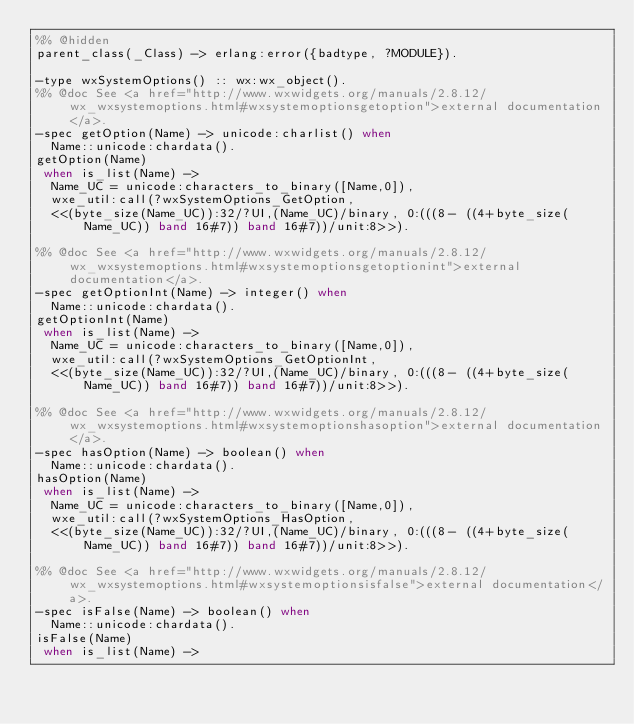<code> <loc_0><loc_0><loc_500><loc_500><_Erlang_>%% @hidden
parent_class(_Class) -> erlang:error({badtype, ?MODULE}).

-type wxSystemOptions() :: wx:wx_object().
%% @doc See <a href="http://www.wxwidgets.org/manuals/2.8.12/wx_wxsystemoptions.html#wxsystemoptionsgetoption">external documentation</a>.
-spec getOption(Name) -> unicode:charlist() when
	Name::unicode:chardata().
getOption(Name)
 when is_list(Name) ->
  Name_UC = unicode:characters_to_binary([Name,0]),
  wxe_util:call(?wxSystemOptions_GetOption,
  <<(byte_size(Name_UC)):32/?UI,(Name_UC)/binary, 0:(((8- ((4+byte_size(Name_UC)) band 16#7)) band 16#7))/unit:8>>).

%% @doc See <a href="http://www.wxwidgets.org/manuals/2.8.12/wx_wxsystemoptions.html#wxsystemoptionsgetoptionint">external documentation</a>.
-spec getOptionInt(Name) -> integer() when
	Name::unicode:chardata().
getOptionInt(Name)
 when is_list(Name) ->
  Name_UC = unicode:characters_to_binary([Name,0]),
  wxe_util:call(?wxSystemOptions_GetOptionInt,
  <<(byte_size(Name_UC)):32/?UI,(Name_UC)/binary, 0:(((8- ((4+byte_size(Name_UC)) band 16#7)) band 16#7))/unit:8>>).

%% @doc See <a href="http://www.wxwidgets.org/manuals/2.8.12/wx_wxsystemoptions.html#wxsystemoptionshasoption">external documentation</a>.
-spec hasOption(Name) -> boolean() when
	Name::unicode:chardata().
hasOption(Name)
 when is_list(Name) ->
  Name_UC = unicode:characters_to_binary([Name,0]),
  wxe_util:call(?wxSystemOptions_HasOption,
  <<(byte_size(Name_UC)):32/?UI,(Name_UC)/binary, 0:(((8- ((4+byte_size(Name_UC)) band 16#7)) band 16#7))/unit:8>>).

%% @doc See <a href="http://www.wxwidgets.org/manuals/2.8.12/wx_wxsystemoptions.html#wxsystemoptionsisfalse">external documentation</a>.
-spec isFalse(Name) -> boolean() when
	Name::unicode:chardata().
isFalse(Name)
 when is_list(Name) -></code> 